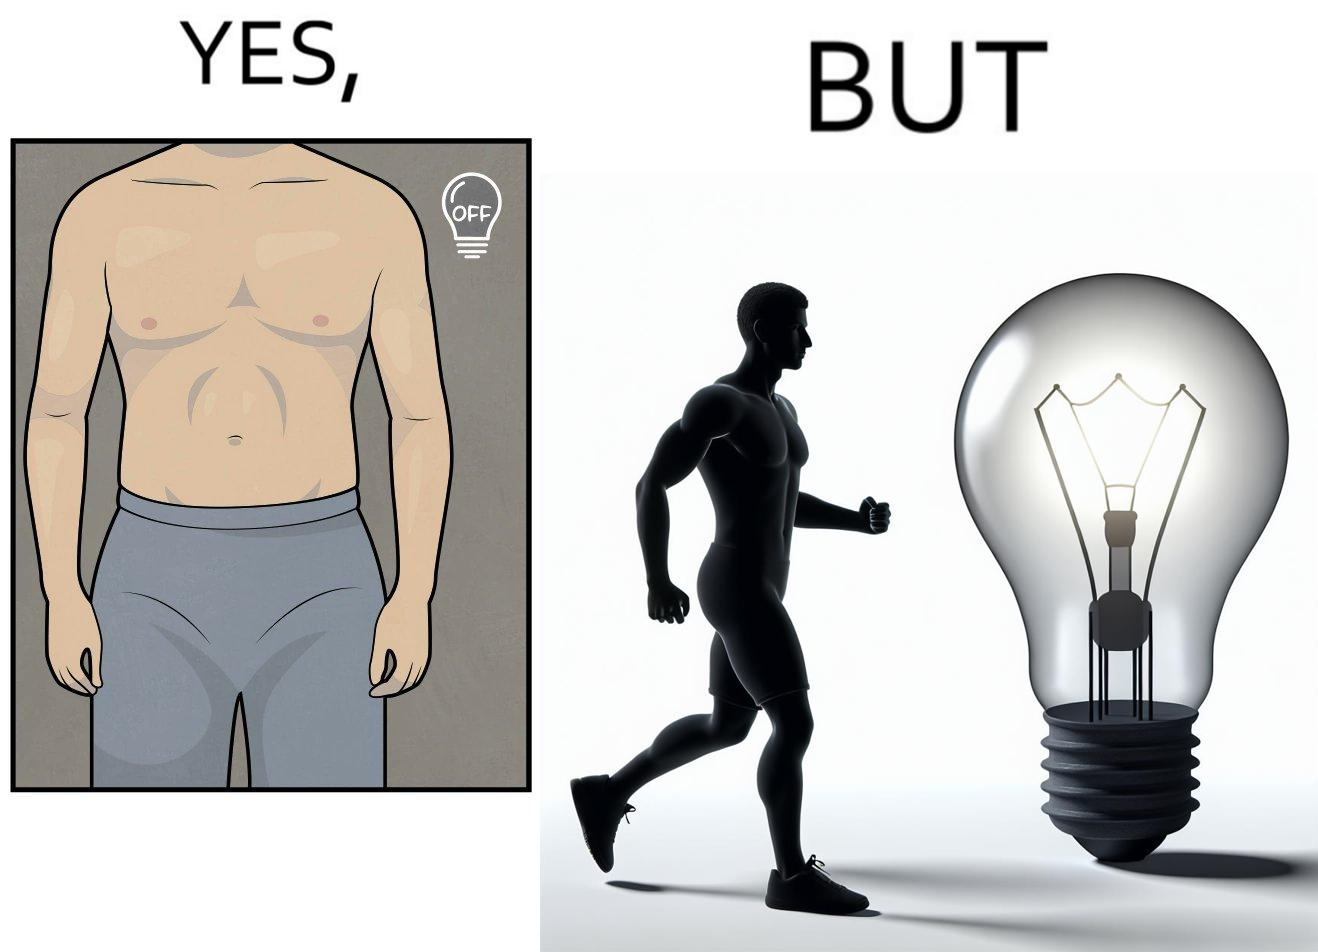Provide a description of this image. The images are funny because it shows the same body in two different lighting conditions, one where it appears muscular and one where it does not appear so. It shows how we can make the same thing appear appealing to others without it being as appealing in real life 